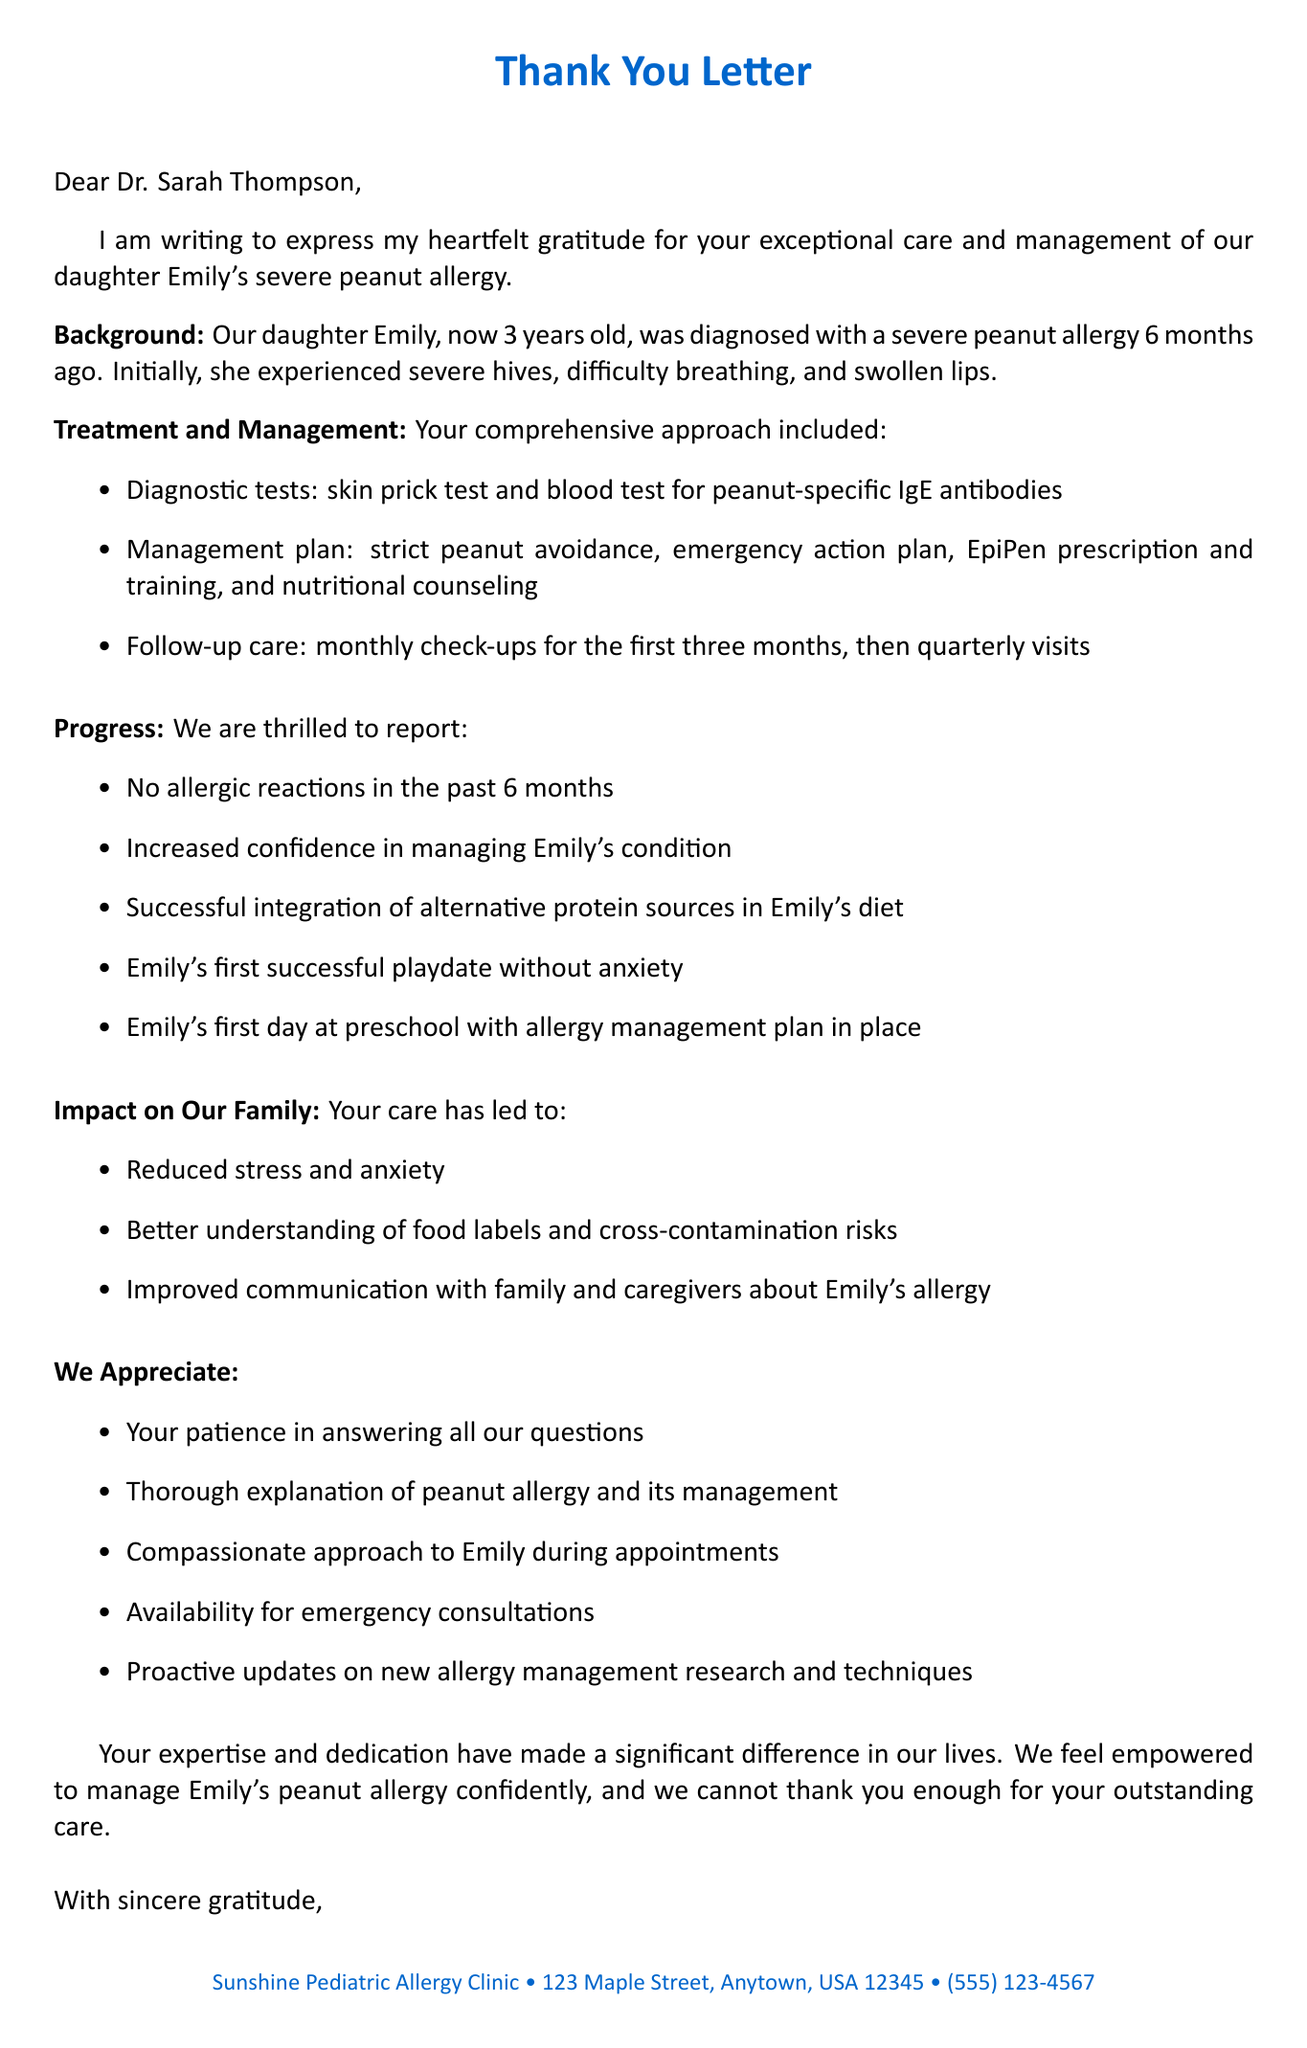What is the child's name? The child's name is mentioned in the letter as Emily.
Answer: Emily Who diagnosed the child? The letter is addressed to Dr. Sarah Thompson, indicating she is the diagnosing physician.
Answer: Dr. Sarah Thompson What are the initial symptoms of the allergy? The letter lists severe hives, difficulty breathing, and swollen lips as the initial symptoms.
Answer: severe hives, difficulty breathing, swollen lips How long has Emily been diagnosed with the allergy? The letter states that Emily was diagnosed 6 months ago.
Answer: 6 months What is one of the milestones mentioned in the letter? The letter lists Emily's first day at preschool as a significant milestone achieved under management.
Answer: Emily's first day at preschool What management plan is included in the treatment details? The management plan includes strict peanut avoidance, among other strategies.
Answer: Strict peanut avoidance What impact did Emily's condition have on her family? The letter mentions reduced stress and anxiety as a positive impact on the family.
Answer: Reduced stress and anxiety Which type of educational resources are mentioned? The letter mentions allergy-safe cookbook recommendations as part of the educational resources.
Answer: Allergy-safe cookbook recommendations What was the tone of the letter? The letter expresses heartfelt gratitude and appreciation for the doctor's care and expertise.
Answer: heartfelt gratitude 